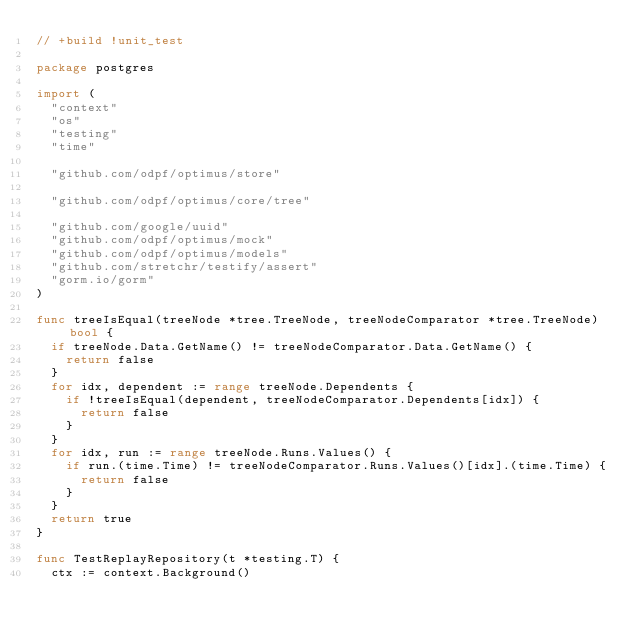<code> <loc_0><loc_0><loc_500><loc_500><_Go_>// +build !unit_test

package postgres

import (
	"context"
	"os"
	"testing"
	"time"

	"github.com/odpf/optimus/store"

	"github.com/odpf/optimus/core/tree"

	"github.com/google/uuid"
	"github.com/odpf/optimus/mock"
	"github.com/odpf/optimus/models"
	"github.com/stretchr/testify/assert"
	"gorm.io/gorm"
)

func treeIsEqual(treeNode *tree.TreeNode, treeNodeComparator *tree.TreeNode) bool {
	if treeNode.Data.GetName() != treeNodeComparator.Data.GetName() {
		return false
	}
	for idx, dependent := range treeNode.Dependents {
		if !treeIsEqual(dependent, treeNodeComparator.Dependents[idx]) {
			return false
		}
	}
	for idx, run := range treeNode.Runs.Values() {
		if run.(time.Time) != treeNodeComparator.Runs.Values()[idx].(time.Time) {
			return false
		}
	}
	return true
}

func TestReplayRepository(t *testing.T) {
	ctx := context.Background()</code> 